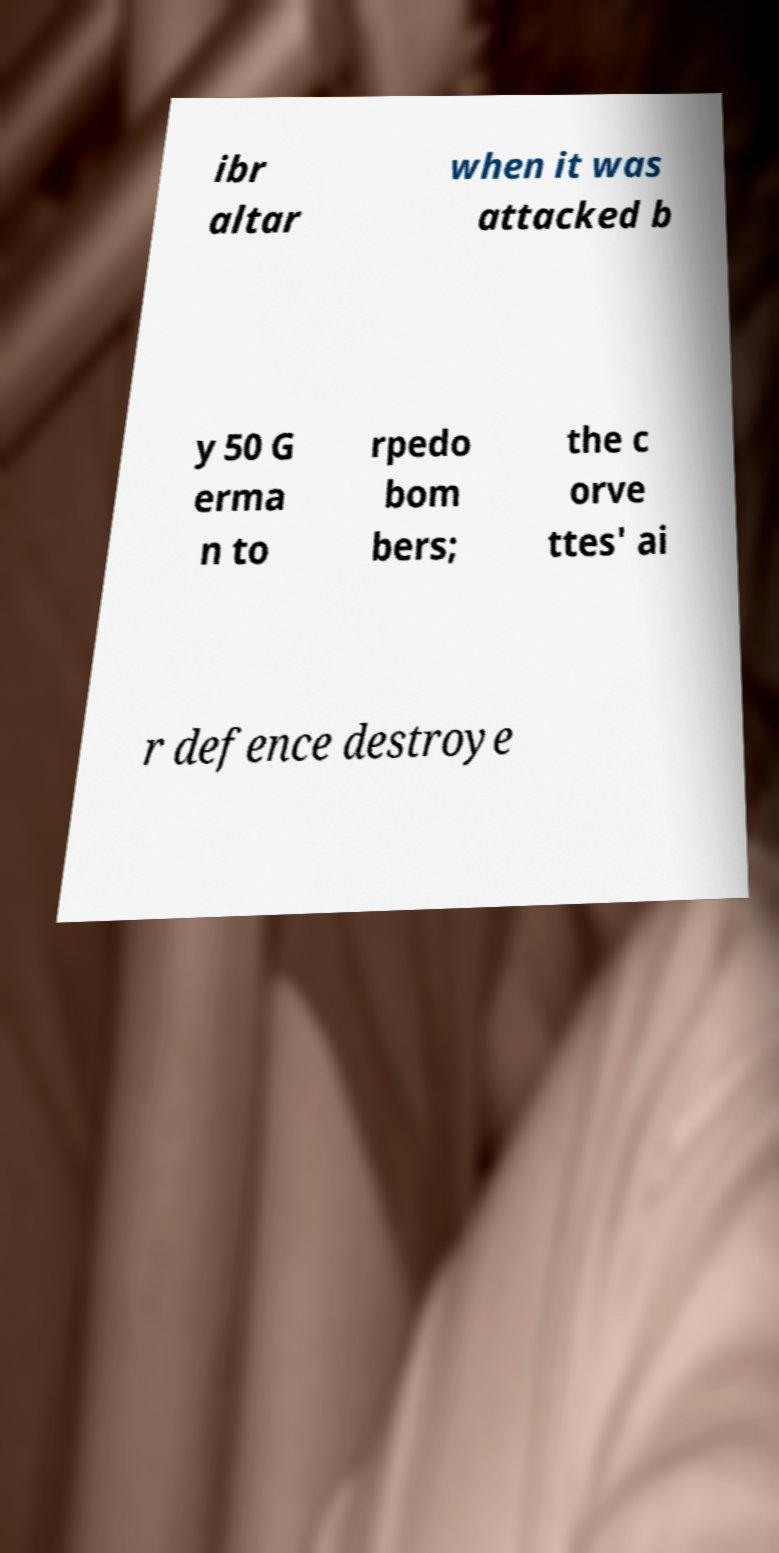Please read and relay the text visible in this image. What does it say? ibr altar when it was attacked b y 50 G erma n to rpedo bom bers; the c orve ttes' ai r defence destroye 